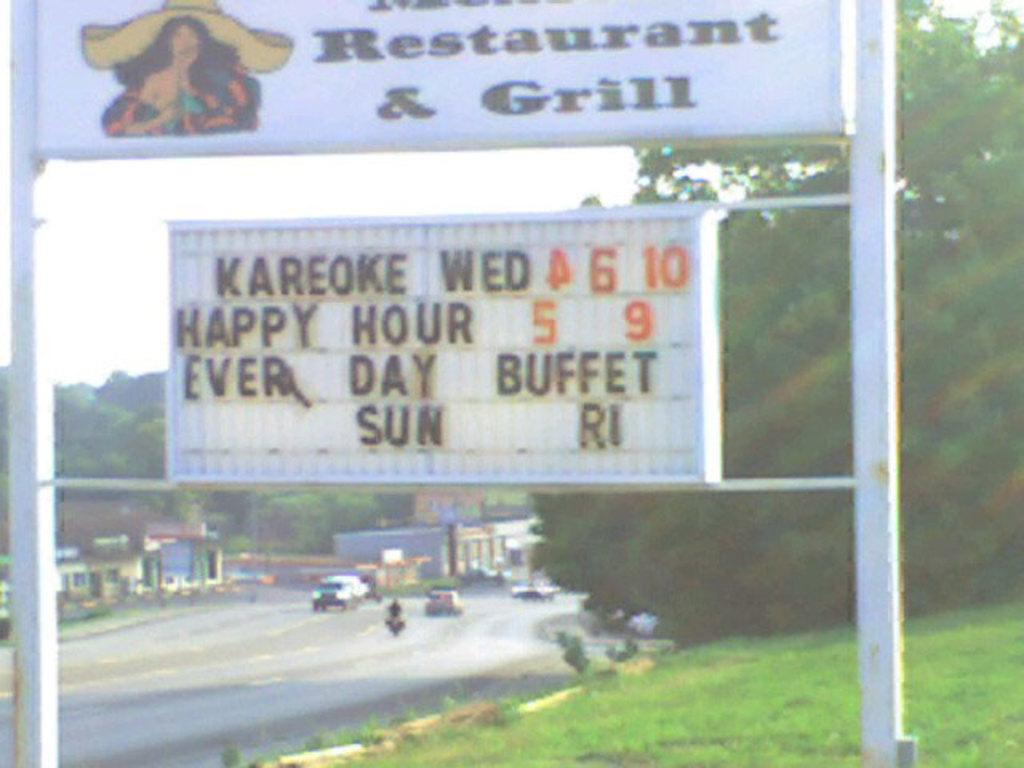<image>
Offer a succinct explanation of the picture presented. A grill and restaurant that will offer happy hour. 